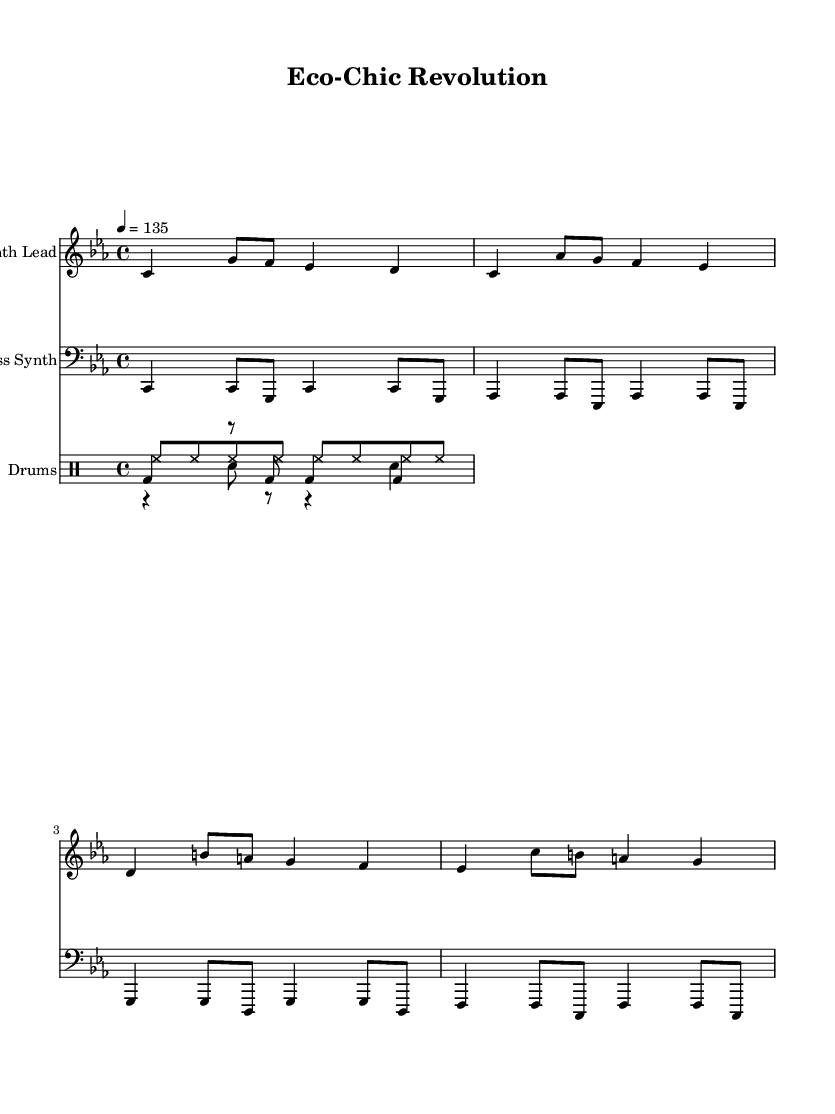What is the key signature of this music? The key signature is C minor, indicated by three flats (B flat, E flat, A flat) which is characteristic of this key.
Answer: C minor What is the time signature of this music? The time signature is 4/4, which is shown at the beginning of the score and is common in electronic music for its straightforward rhythmic structure.
Answer: 4/4 What is the tempo marking given? The tempo marking is 135 beats per minute, indicated at the beginning of the score which directs the pace of the piece.
Answer: 135 How many instruments are indicated in the score? The score indicates three distinct instruments: one for the synth lead, one for the bass synth, and a drum staff containing kick, snare, and hi-hat.
Answer: Three Which instrument has the highest pitch in the score? The highest pitch is found in the Synth Lead staff, where the notes rise significantly higher than those in the bass synth or drums.
Answer: Synth Lead How many measures are present in the synth lead section? The synth lead section contains four measures, counted from the opening to the end of the written section, consistent with the time signature.
Answer: Four What type of musical style is this composition? This composition is classified as avant-garde industrial techno, which is evident from the use of synthesized sounds and rhythmic patterns typical of the electronic genre.
Answer: Avant-garde industrial techno 